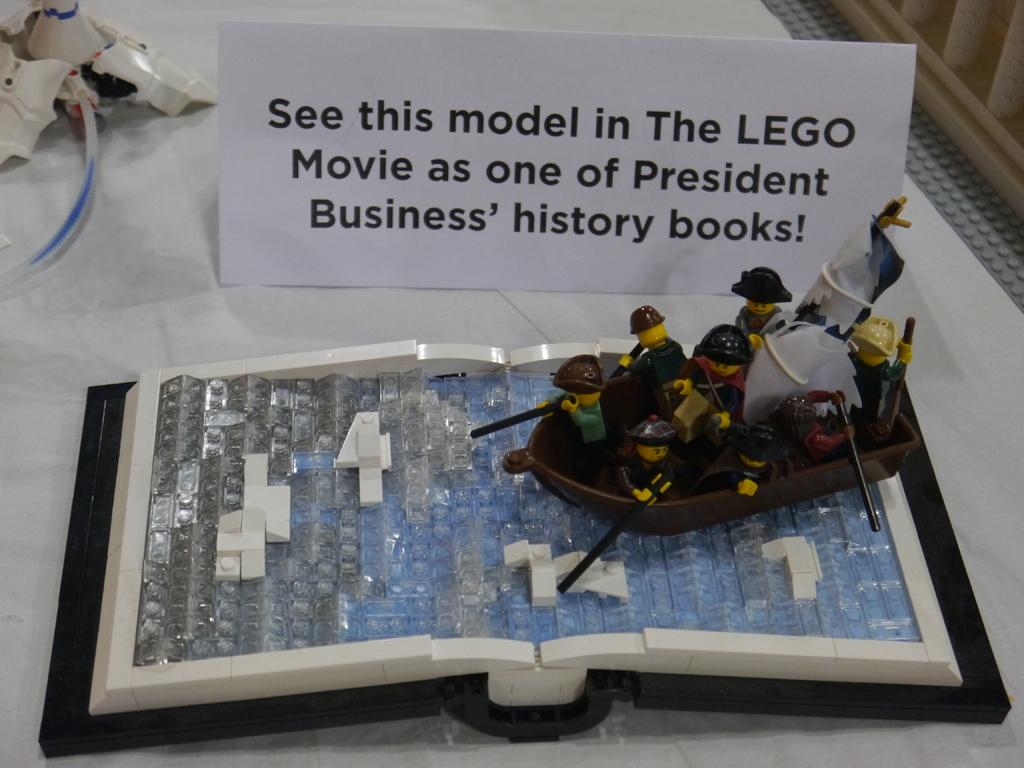What type of model can be seen in the image? There is a Lego model in the image. What is written or drawn on the whiteboard in the image? There is text on a whiteboard in the image. What other objects can be seen on a white surface in the image? There are a few objects visible on a white surface in the image. What type of metal is used to create the crack in the Lego model? There is no crack in the Lego model, and no mention of metal in the image. 